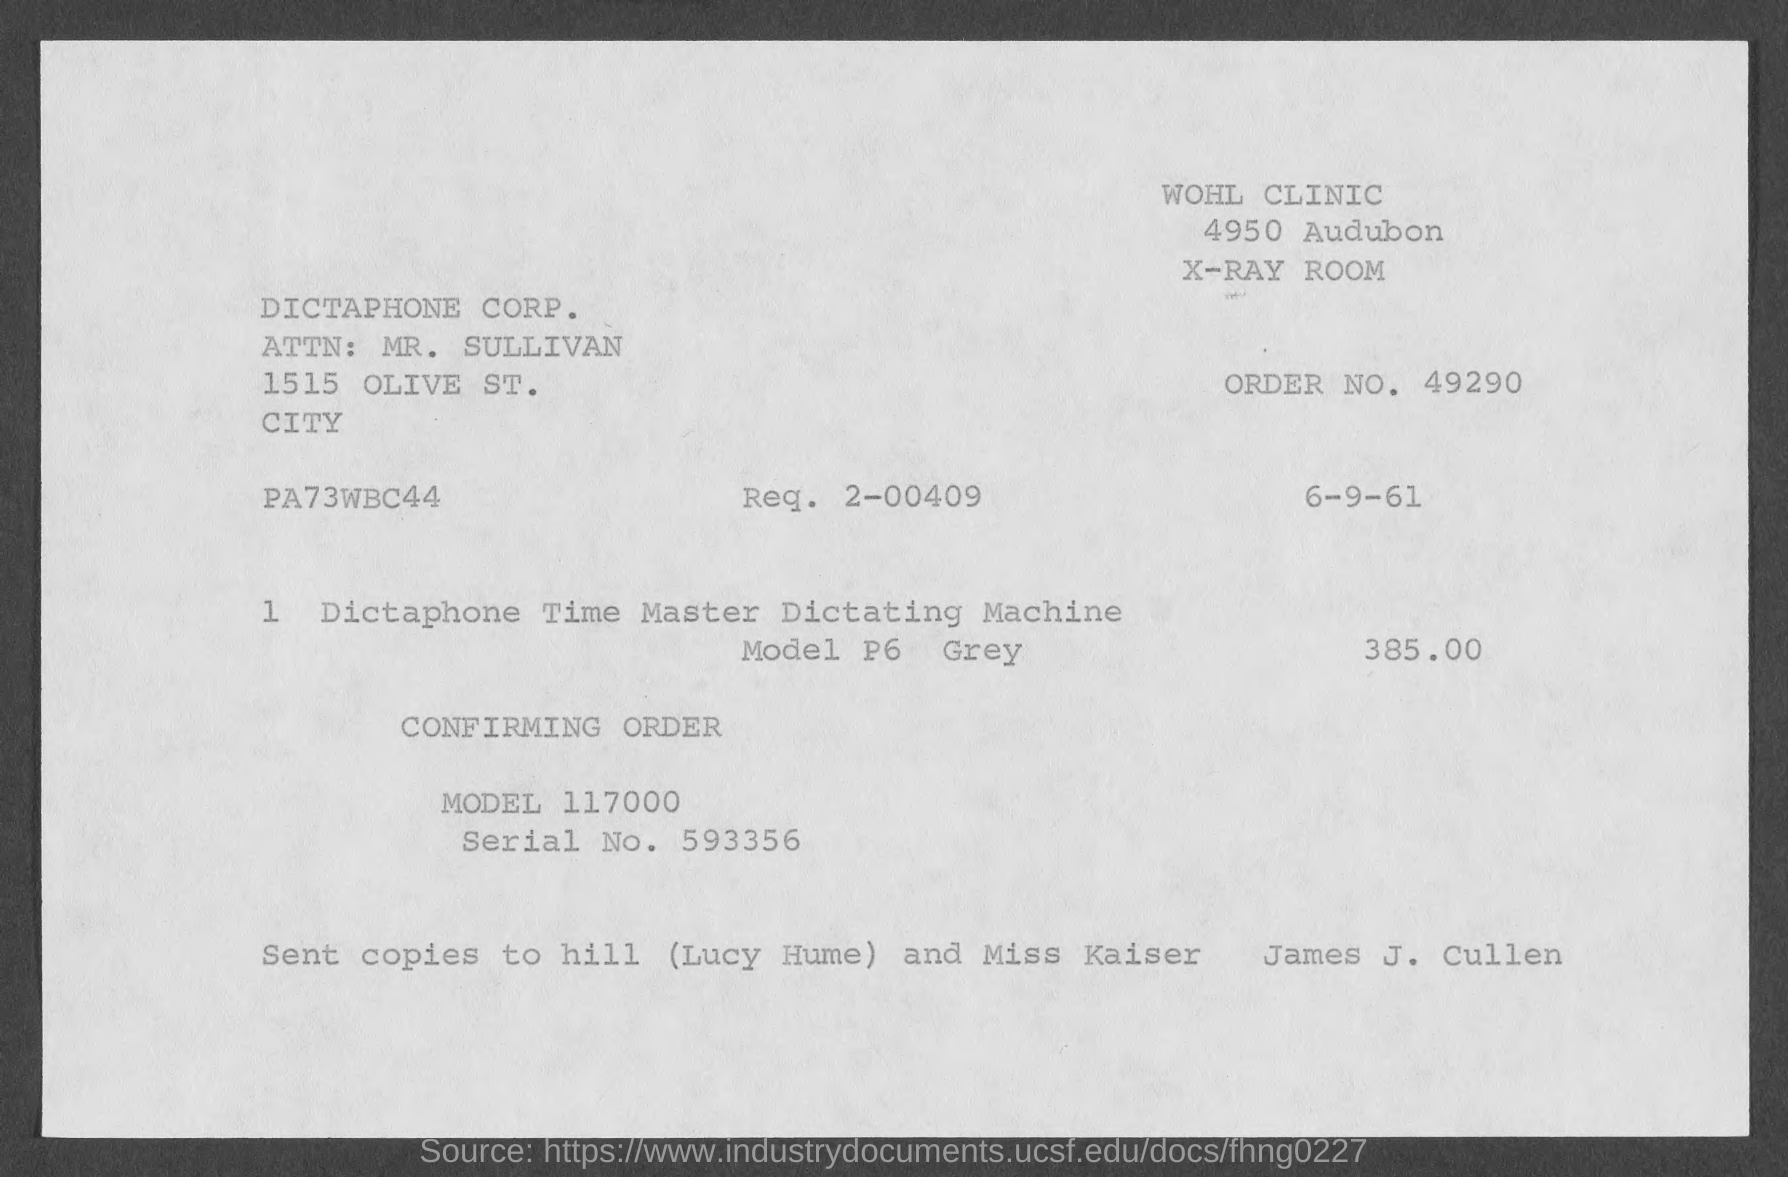What is the order no. ?
Your answer should be very brief. 49290. What is the req. no?
Your answer should be very brief. 2-00409. What is the model no.?
Provide a succinct answer. 117000. What is the serial no.?
Your answer should be very brief. 593356. What is the attn. person name?
Make the answer very short. Mr. sullivan. 